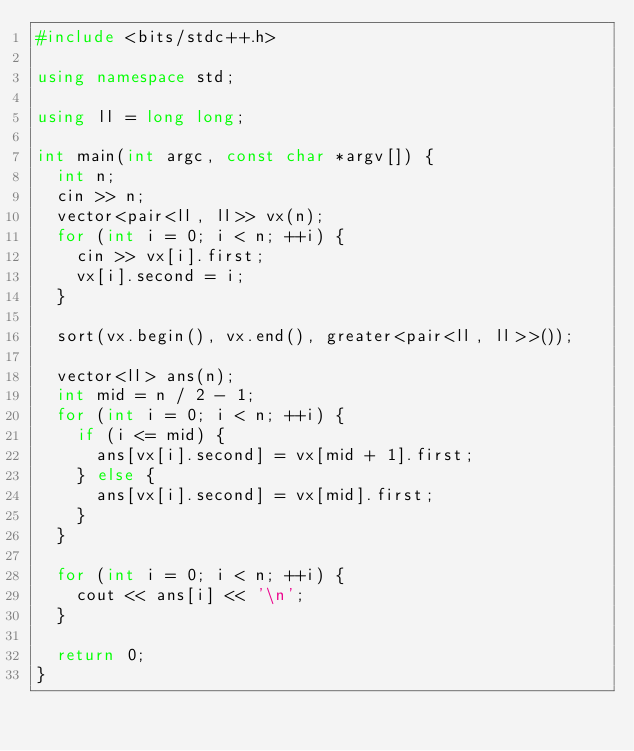Convert code to text. <code><loc_0><loc_0><loc_500><loc_500><_C++_>#include <bits/stdc++.h>

using namespace std;

using ll = long long;

int main(int argc, const char *argv[]) {
  int n;
  cin >> n;
  vector<pair<ll, ll>> vx(n);
  for (int i = 0; i < n; ++i) {
    cin >> vx[i].first;
    vx[i].second = i;
  }

  sort(vx.begin(), vx.end(), greater<pair<ll, ll>>());

  vector<ll> ans(n);
  int mid = n / 2 - 1;
  for (int i = 0; i < n; ++i) {
    if (i <= mid) {
      ans[vx[i].second] = vx[mid + 1].first;
    } else {
      ans[vx[i].second] = vx[mid].first;
    }
  }

  for (int i = 0; i < n; ++i) {
    cout << ans[i] << '\n';
  }

  return 0;
}</code> 